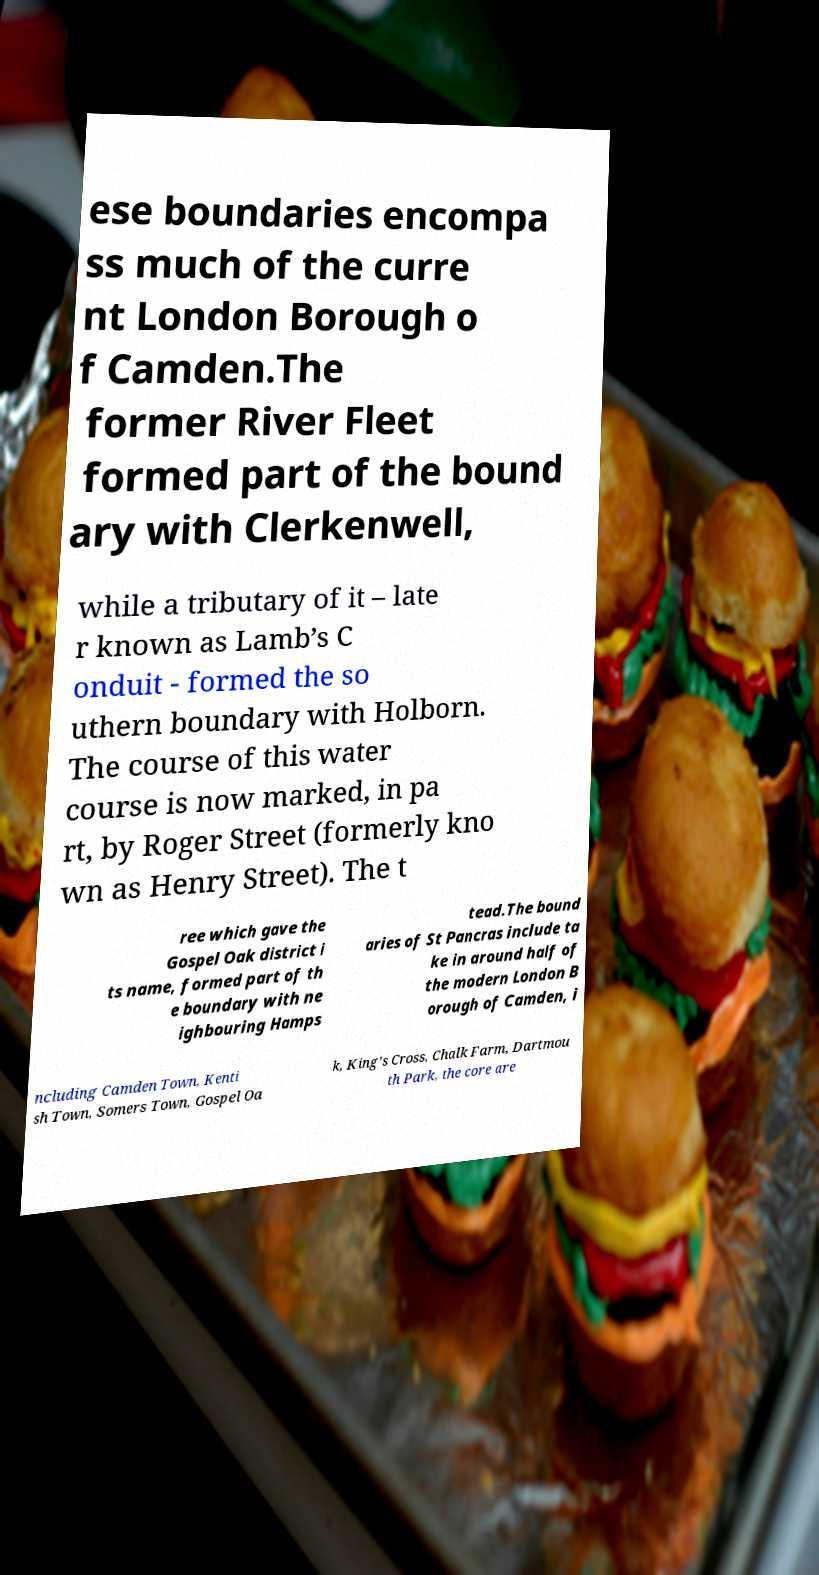Could you assist in decoding the text presented in this image and type it out clearly? ese boundaries encompa ss much of the curre nt London Borough o f Camden.The former River Fleet formed part of the bound ary with Clerkenwell, while a tributary of it – late r known as Lamb’s C onduit - formed the so uthern boundary with Holborn. The course of this water course is now marked, in pa rt, by Roger Street (formerly kno wn as Henry Street). The t ree which gave the Gospel Oak district i ts name, formed part of th e boundary with ne ighbouring Hamps tead.The bound aries of St Pancras include ta ke in around half of the modern London B orough of Camden, i ncluding Camden Town, Kenti sh Town, Somers Town, Gospel Oa k, King's Cross, Chalk Farm, Dartmou th Park, the core are 